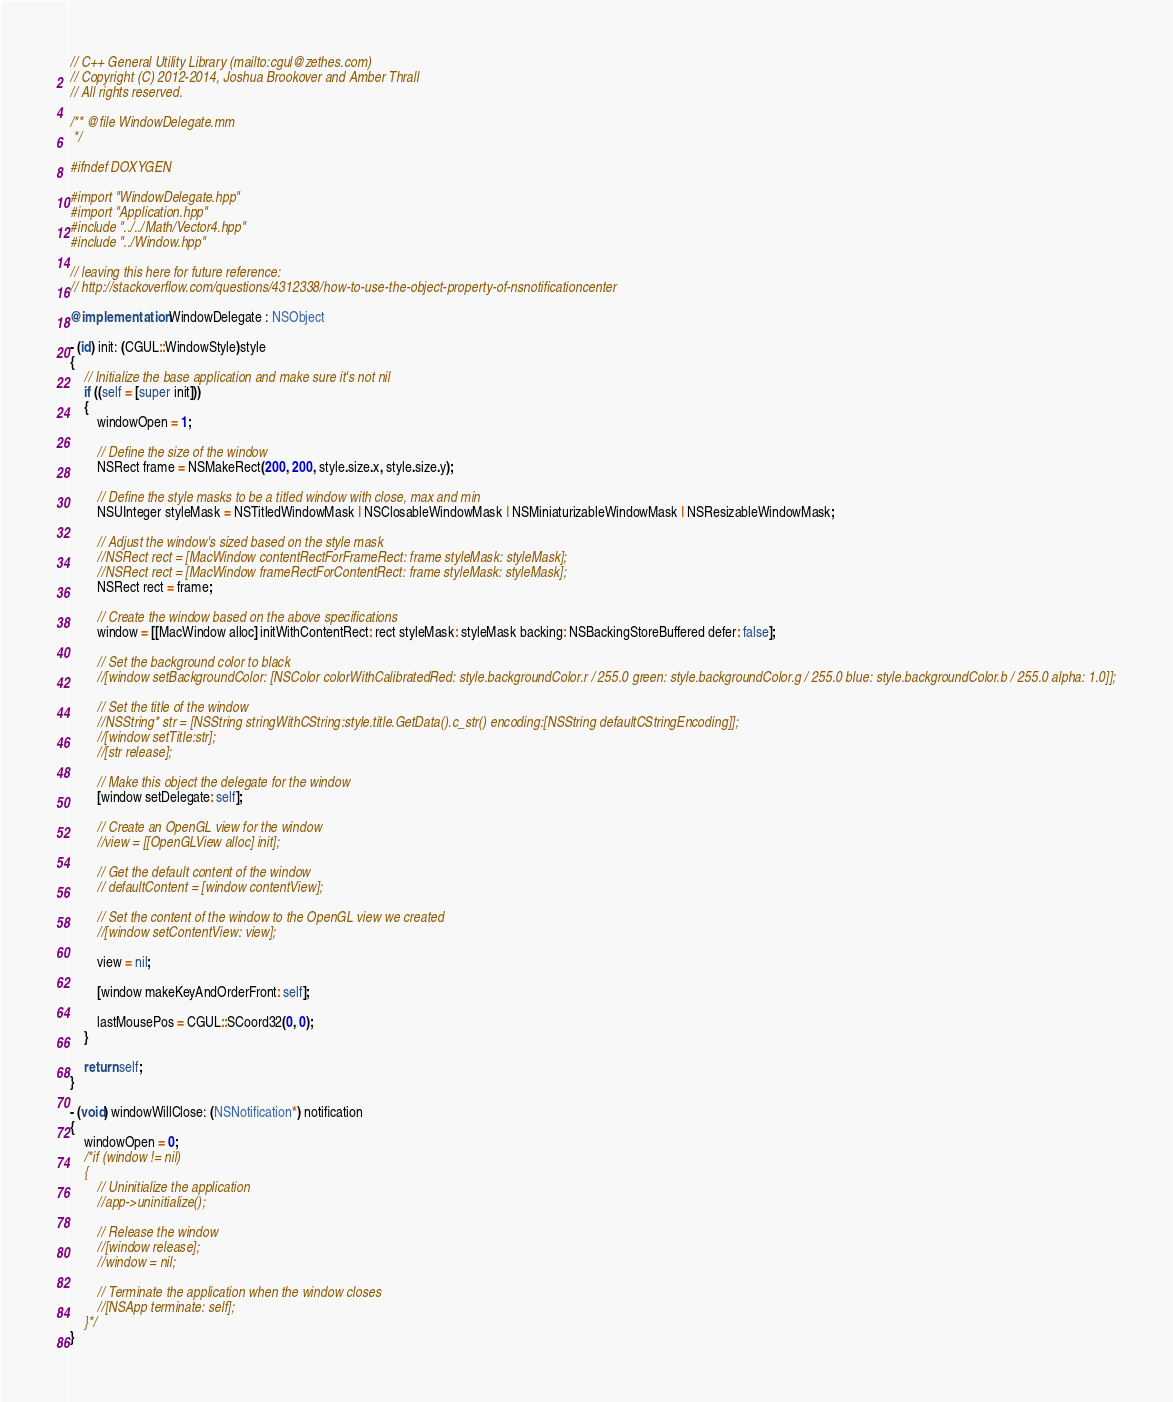Convert code to text. <code><loc_0><loc_0><loc_500><loc_500><_ObjectiveC_>// C++ General Utility Library (mailto:cgul@zethes.com)
// Copyright (C) 2012-2014, Joshua Brookover and Amber Thrall
// All rights reserved.

/** @file WindowDelegate.mm
 */

#ifndef DOXYGEN

#import "WindowDelegate.hpp"
#import "Application.hpp"
#include "../../Math/Vector4.hpp"
#include "../Window.hpp"

// leaving this here for future reference:
// http://stackoverflow.com/questions/4312338/how-to-use-the-object-property-of-nsnotificationcenter

@implementation WindowDelegate : NSObject

- (id) init: (CGUL::WindowStyle)style
{
    // Initialize the base application and make sure it's not nil
    if ((self = [super init]))
    {
        windowOpen = 1;

        // Define the size of the window
        NSRect frame = NSMakeRect(200, 200, style.size.x, style.size.y);

        // Define the style masks to be a titled window with close, max and min
        NSUInteger styleMask = NSTitledWindowMask | NSClosableWindowMask | NSMiniaturizableWindowMask | NSResizableWindowMask;

        // Adjust the window's sized based on the style mask
        //NSRect rect = [MacWindow contentRectForFrameRect: frame styleMask: styleMask];
        //NSRect rect = [MacWindow frameRectForContentRect: frame styleMask: styleMask];
        NSRect rect = frame;

        // Create the window based on the above specifications
        window = [[MacWindow alloc] initWithContentRect: rect styleMask: styleMask backing: NSBackingStoreBuffered defer: false];

        // Set the background color to black
        //[window setBackgroundColor: [NSColor colorWithCalibratedRed: style.backgroundColor.r / 255.0 green: style.backgroundColor.g / 255.0 blue: style.backgroundColor.b / 255.0 alpha: 1.0]];

        // Set the title of the window
        //NSString* str = [NSString stringWithCString:style.title.GetData().c_str() encoding:[NSString defaultCStringEncoding]];
        //[window setTitle:str];
        //[str release];

        // Make this object the delegate for the window
        [window setDelegate: self];

        // Create an OpenGL view for the window
        //view = [[OpenGLView alloc] init];

        // Get the default content of the window
        // defaultContent = [window contentView];

        // Set the content of the window to the OpenGL view we created
        //[window setContentView: view];

        view = nil;

        [window makeKeyAndOrderFront: self];

        lastMousePos = CGUL::SCoord32(0, 0);
    }

    return self;
}

- (void) windowWillClose: (NSNotification*) notification
{
    windowOpen = 0;
    /*if (window != nil)
    {
        // Uninitialize the application
        //app->uninitialize();

        // Release the window
        //[window release];
        //window = nil;

        // Terminate the application when the window closes
        //[NSApp terminate: self];
    }*/
}
</code> 